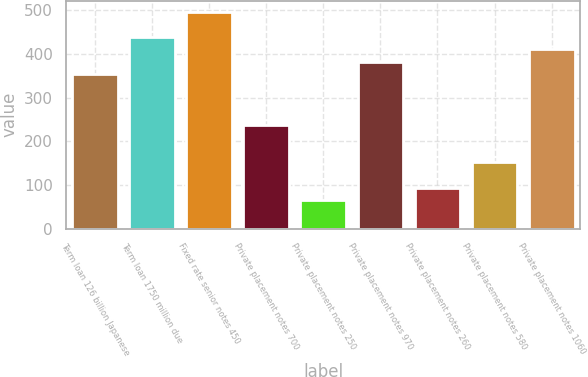<chart> <loc_0><loc_0><loc_500><loc_500><bar_chart><fcel>Term loan 126 billion Japanese<fcel>Term loan 1750 million due<fcel>Fixed rate senior notes 450<fcel>Private placement notes 700<fcel>Private placement notes 250<fcel>Private placement notes 970<fcel>Private placement notes 260<fcel>Private placement notes 580<fcel>Private placement notes 1060<nl><fcel>353.3<fcel>439.7<fcel>497.3<fcel>238.1<fcel>65.3<fcel>382.1<fcel>94.1<fcel>151.7<fcel>410.9<nl></chart> 